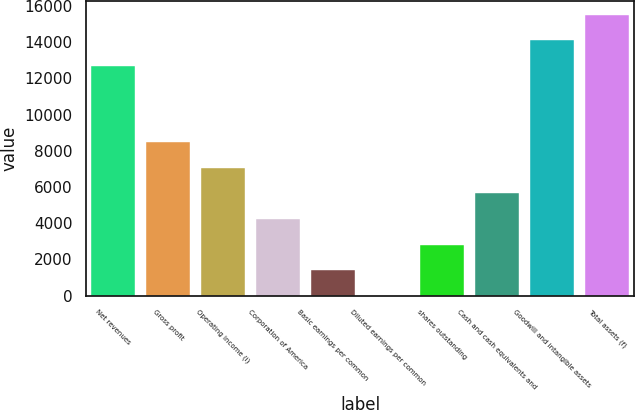<chart> <loc_0><loc_0><loc_500><loc_500><bar_chart><fcel>Net revenues<fcel>Gross profit<fcel>Operating income (i)<fcel>Corporation of America<fcel>Basic earnings per common<fcel>Diluted earnings per common<fcel>shares outstanding<fcel>Cash and cash equivalents and<fcel>Goodwill and intangible assets<fcel>Total assets (f)<nl><fcel>12694.7<fcel>8464.58<fcel>7054.54<fcel>4234.46<fcel>1414.38<fcel>4.34<fcel>2824.42<fcel>5644.5<fcel>14104.7<fcel>15514.8<nl></chart> 